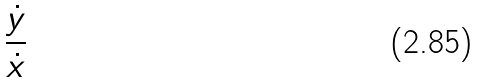<formula> <loc_0><loc_0><loc_500><loc_500>\frac { \dot { y } } { \dot { x } }</formula> 